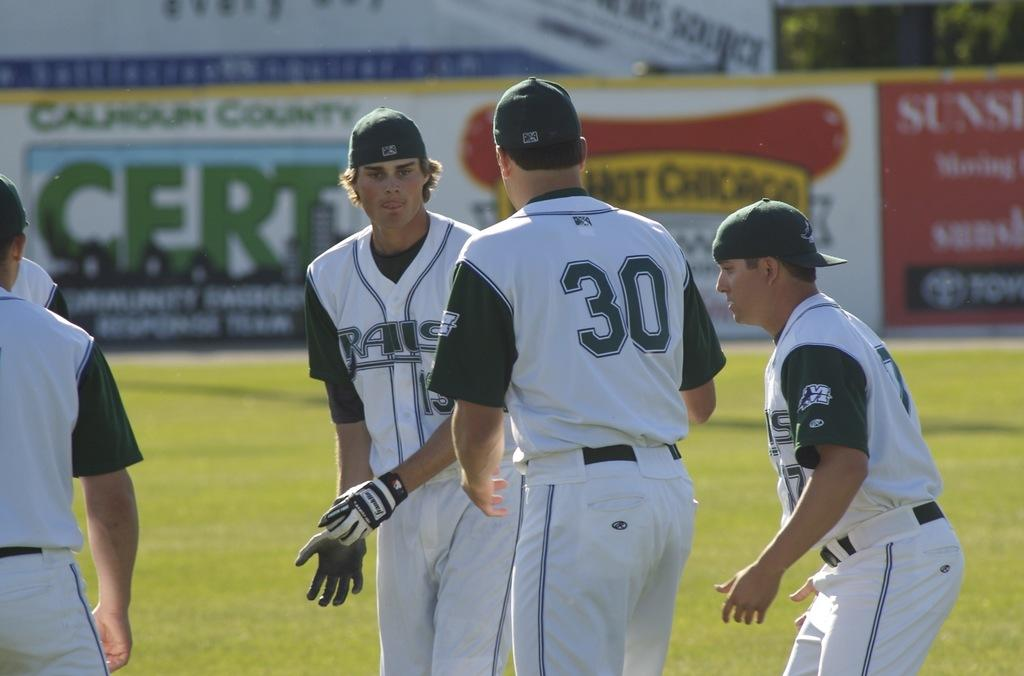<image>
Create a compact narrative representing the image presented. a player with the number 30 on his back 